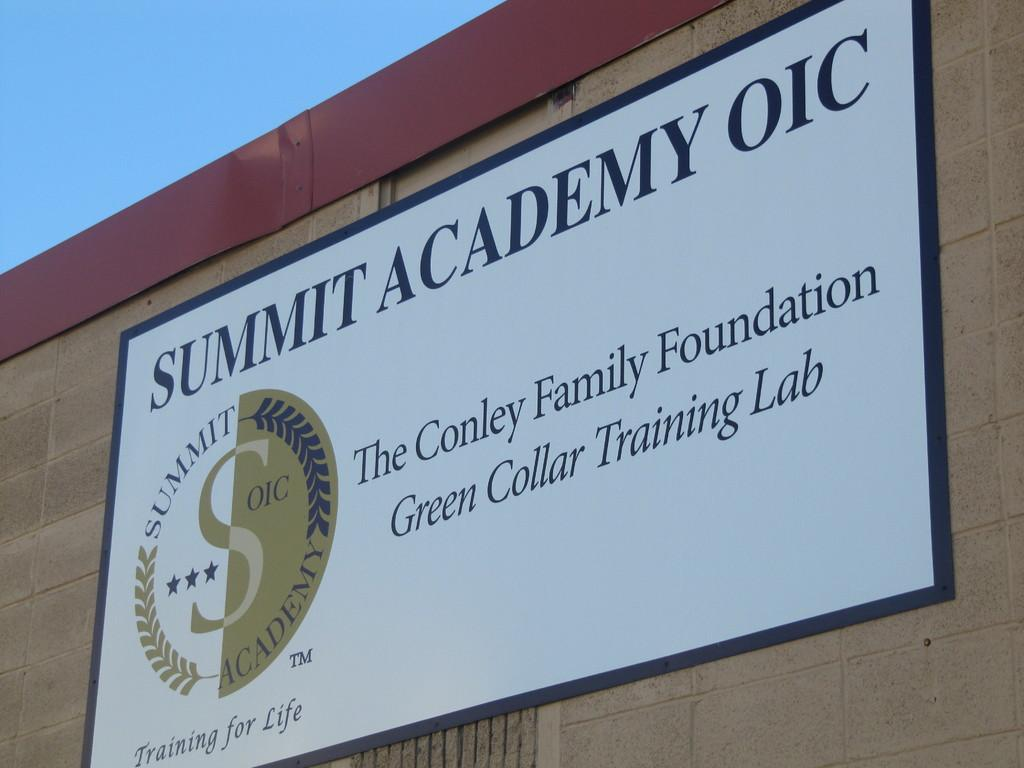Provide a one-sentence caption for the provided image. A sign on a building that says Summit Academy OIC. 